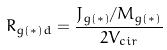Convert formula to latex. <formula><loc_0><loc_0><loc_500><loc_500>R _ { g ( * ) d } = \frac { J _ { g ( * ) } / M _ { g ( * ) } } { 2 V _ { c i r } }</formula> 